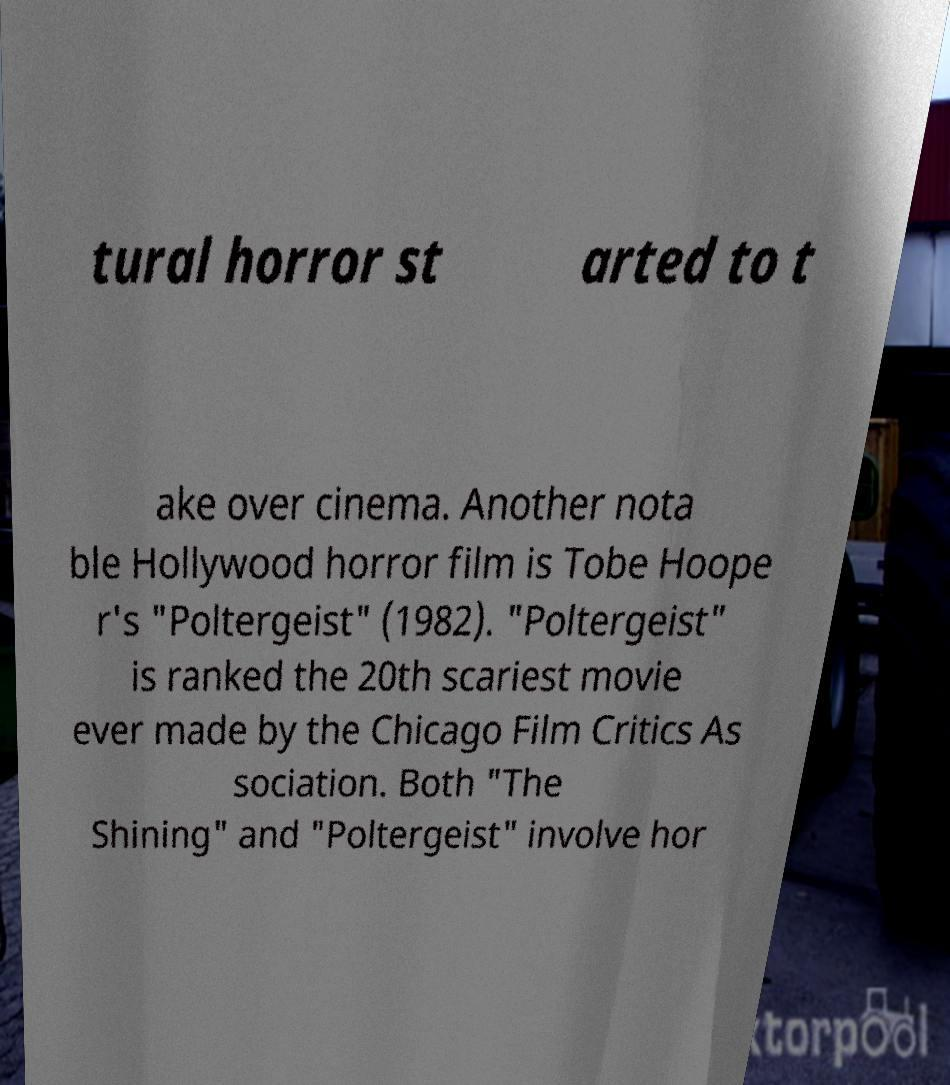I need the written content from this picture converted into text. Can you do that? tural horror st arted to t ake over cinema. Another nota ble Hollywood horror film is Tobe Hoope r's "Poltergeist" (1982). "Poltergeist" is ranked the 20th scariest movie ever made by the Chicago Film Critics As sociation. Both "The Shining" and "Poltergeist" involve hor 